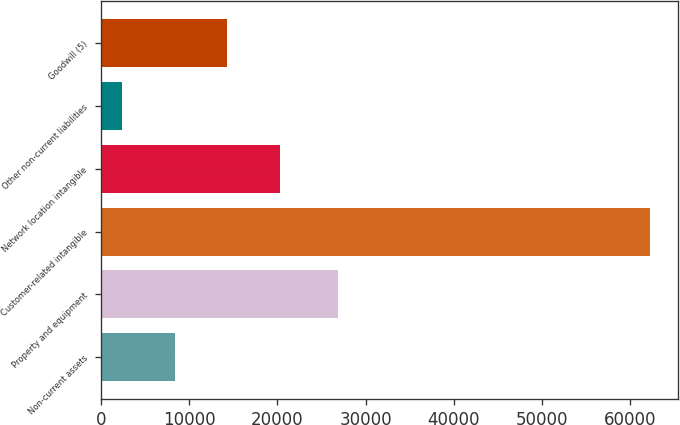<chart> <loc_0><loc_0><loc_500><loc_500><bar_chart><fcel>Non-current assets<fcel>Property and equipment<fcel>Customer-related intangible<fcel>Network location intangible<fcel>Other non-current liabilities<fcel>Goodwill (5)<nl><fcel>8326.5<fcel>26881<fcel>62286<fcel>20317.5<fcel>2331<fcel>14322<nl></chart> 